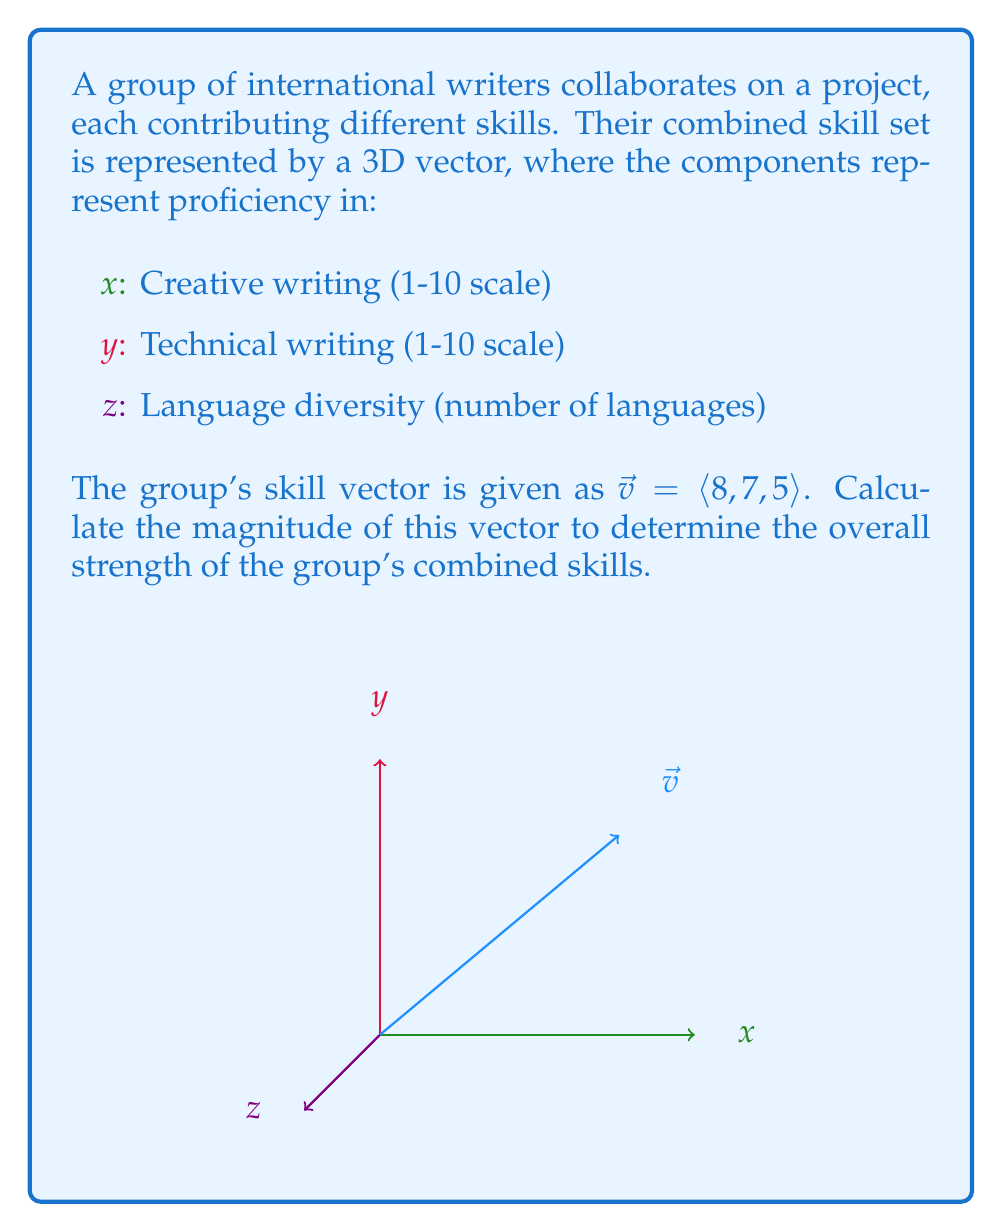Can you answer this question? To calculate the magnitude of a 3D vector, we use the formula:

$$|\vec{v}| = \sqrt{x^2 + y^2 + z^2}$$

Where $x$, $y$, and $z$ are the components of the vector.

Given $\vec{v} = \langle 8, 7, 5 \rangle$, we have:
$x = 8$ (Creative writing)
$y = 7$ (Technical writing)
$z = 5$ (Language diversity)

Let's substitute these values into the formula:

$$|\vec{v}| = \sqrt{8^2 + 7^2 + 5^2}$$

Now, let's calculate:

$$|\vec{v}| = \sqrt{64 + 49 + 25}$$
$$|\vec{v}| = \sqrt{138}$$

The square root of 138 is approximately 11.7473.

Therefore, the magnitude of the vector representing the group's combined skills is approximately 11.75 (rounded to two decimal places).
Answer: $11.75$ 